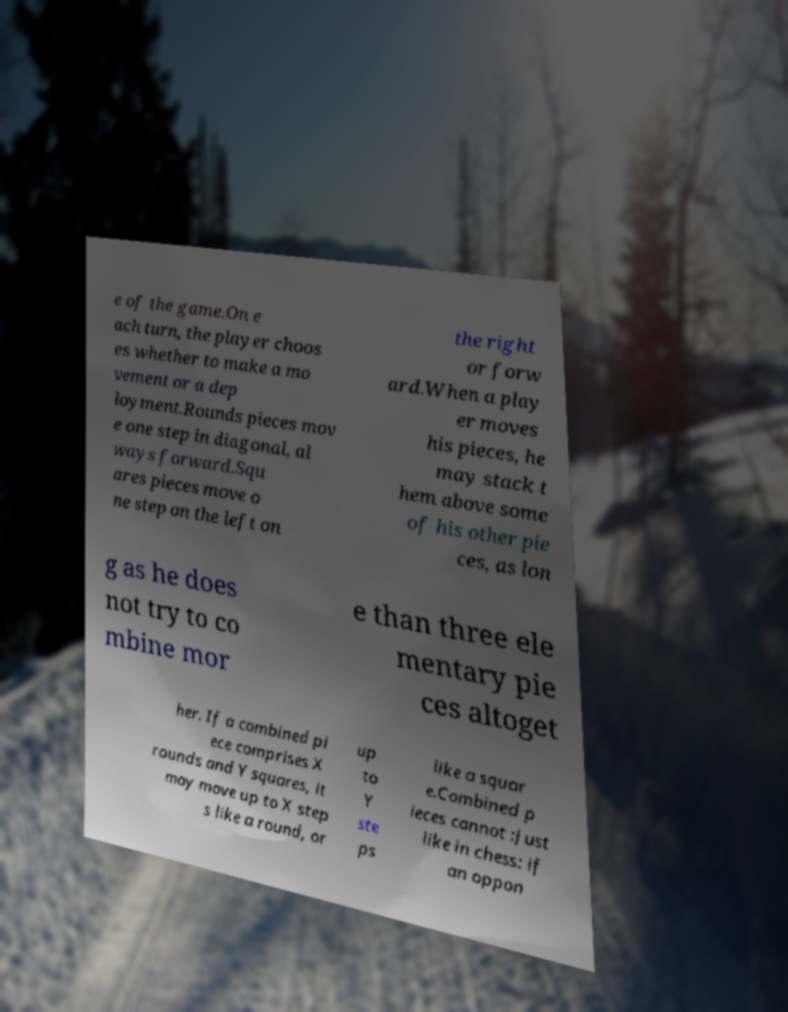What messages or text are displayed in this image? I need them in a readable, typed format. e of the game.On e ach turn, the player choos es whether to make a mo vement or a dep loyment.Rounds pieces mov e one step in diagonal, al ways forward.Squ ares pieces move o ne step on the left on the right or forw ard.When a play er moves his pieces, he may stack t hem above some of his other pie ces, as lon g as he does not try to co mbine mor e than three ele mentary pie ces altoget her. If a combined pi ece comprises X rounds and Y squares, it may move up to X step s like a round, or up to Y ste ps like a squar e.Combined p ieces cannot :Just like in chess: if an oppon 